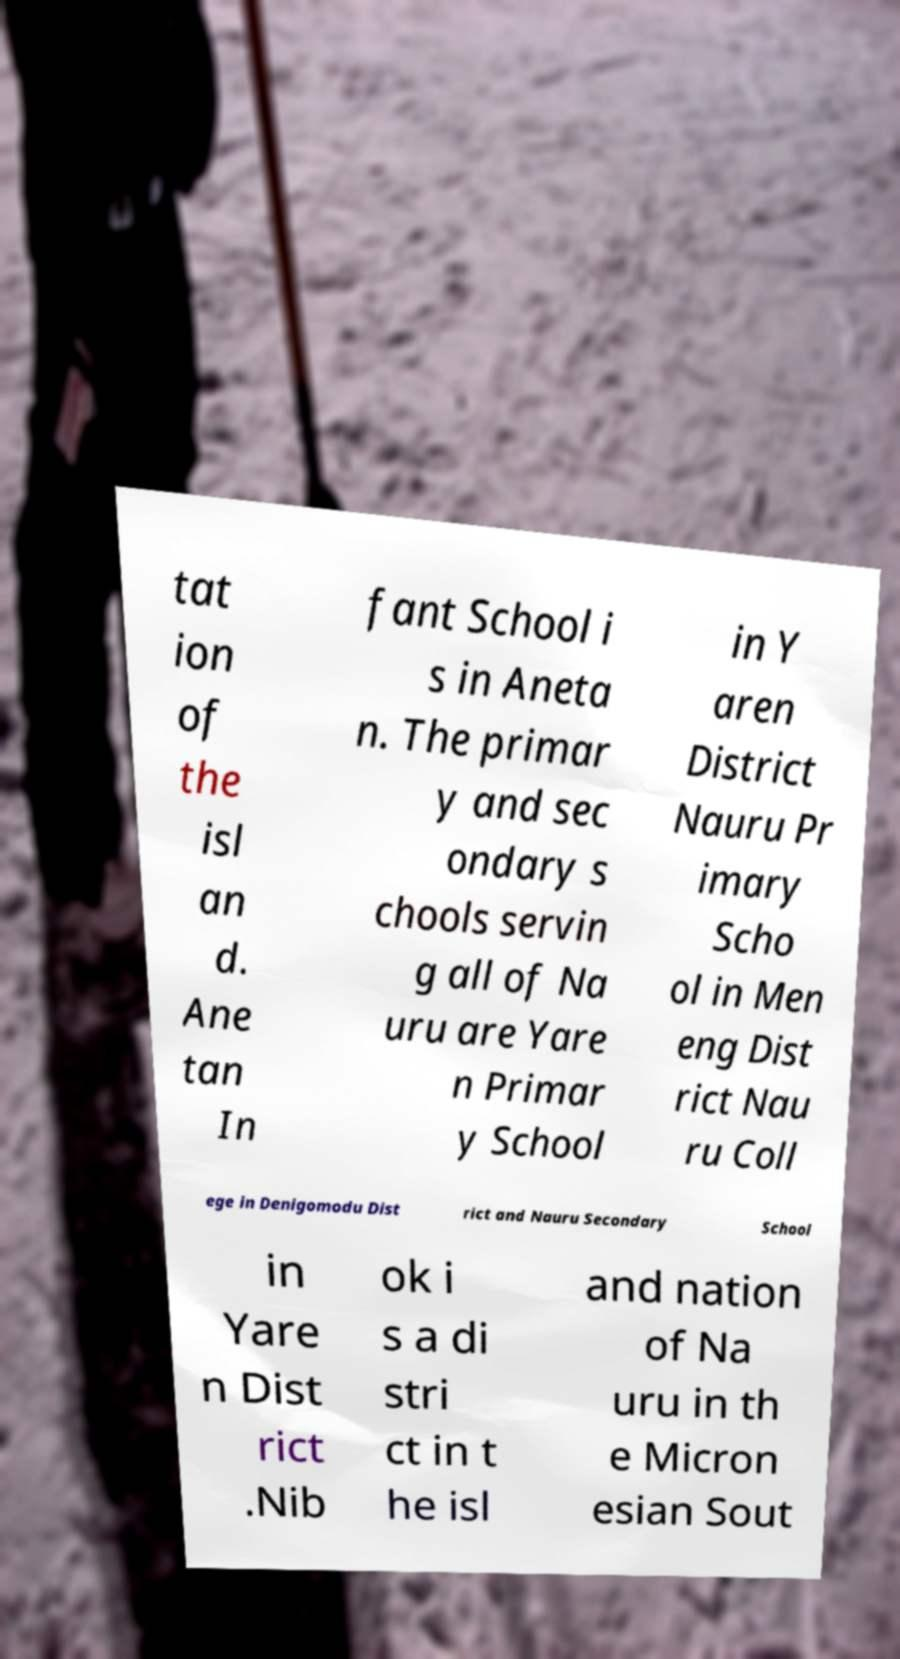Could you extract and type out the text from this image? tat ion of the isl an d. Ane tan In fant School i s in Aneta n. The primar y and sec ondary s chools servin g all of Na uru are Yare n Primar y School in Y aren District Nauru Pr imary Scho ol in Men eng Dist rict Nau ru Coll ege in Denigomodu Dist rict and Nauru Secondary School in Yare n Dist rict .Nib ok i s a di stri ct in t he isl and nation of Na uru in th e Micron esian Sout 